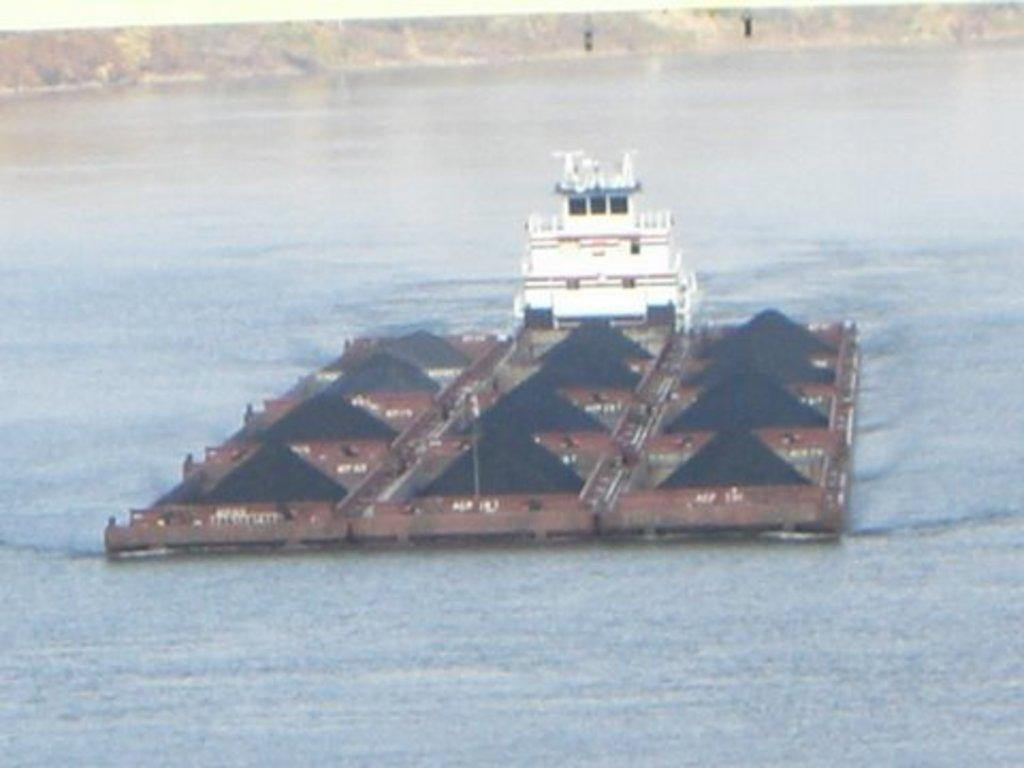What is the primary element visible in the image? There is water in the image. What can be seen in the water? There is a brown-colored platform and a white-colored boat in the water. What is on the platform? There are black-colored objects on the platform. Can you see a person playing with a hose in the image? There is no person or hose present in the image. 